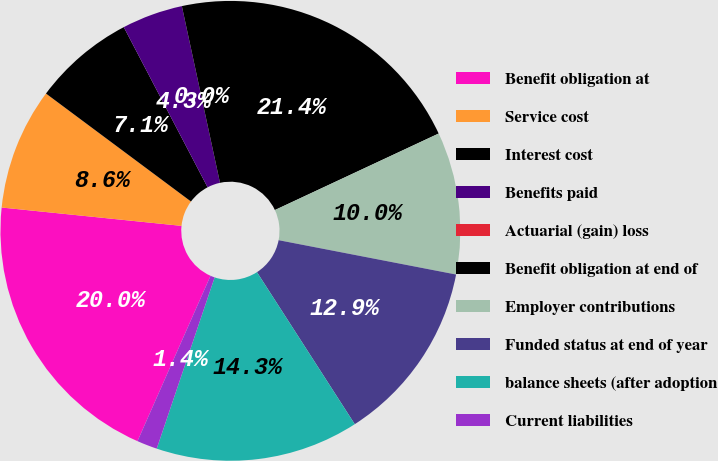Convert chart. <chart><loc_0><loc_0><loc_500><loc_500><pie_chart><fcel>Benefit obligation at<fcel>Service cost<fcel>Interest cost<fcel>Benefits paid<fcel>Actuarial (gain) loss<fcel>Benefit obligation at end of<fcel>Employer contributions<fcel>Funded status at end of year<fcel>balance sheets (after adoption<fcel>Current liabilities<nl><fcel>20.0%<fcel>8.57%<fcel>7.14%<fcel>4.29%<fcel>0.0%<fcel>21.43%<fcel>10.0%<fcel>12.86%<fcel>14.29%<fcel>1.43%<nl></chart> 